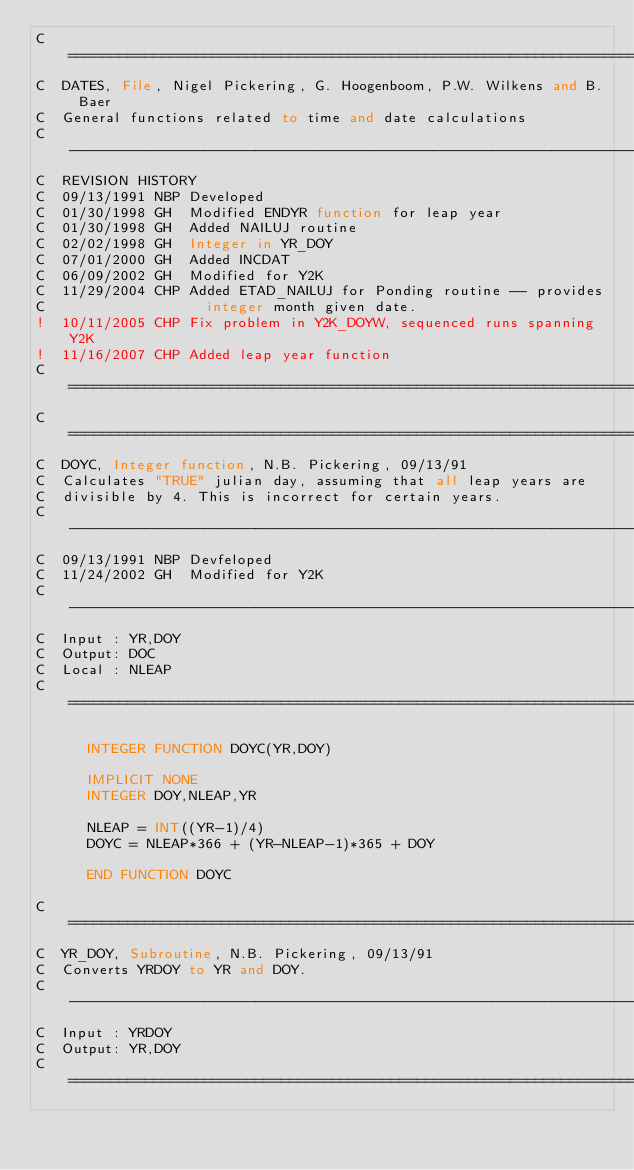Convert code to text. <code><loc_0><loc_0><loc_500><loc_500><_FORTRAN_>C=======================================================================
C  DATES, File, Nigel Pickering, G. Hoogenboom, P.W. Wilkens and B. Baer
C  General functions related to time and date calculations
C-----------------------------------------------------------------------
C  REVISION HISTORY
C  09/13/1991 NBP Developed
C  01/30/1998 GH  Modified ENDYR function for leap year
C  01/30/1998 GH  Added NAILUJ routine
C  02/02/1998 GH  Integer in YR_DOY
C  07/01/2000 GH  Added INCDAT
C  06/09/2002 GH  Modified for Y2K
C  11/29/2004 CHP Added ETAD_NAILUJ for Ponding routine -- provides 
C                   integer month given date.
!  10/11/2005 CHP Fix problem in Y2K_DOYW, sequenced runs spanning Y2K 
!  11/16/2007 CHP Added leap year function
C=======================================================================
C=======================================================================
C  DOYC, Integer function, N.B. Pickering, 09/13/91
C  Calculates "TRUE" julian day, assuming that all leap years are 
C  divisible by 4. This is incorrect for certain years.
C-----------------------------------------------------------------------
C  09/13/1991 NBP Devfeloped
C  11/24/2002 GH  Modified for Y2K
C-----------------------------------------------------------------------
C  Input : YR,DOY
C  Output: DOC
C  Local : NLEAP
C=======================================================================

      INTEGER FUNCTION DOYC(YR,DOY)

      IMPLICIT NONE
      INTEGER DOY,NLEAP,YR

      NLEAP = INT((YR-1)/4)
      DOYC = NLEAP*366 + (YR-NLEAP-1)*365 + DOY

      END FUNCTION DOYC

C=======================================================================
C  YR_DOY, Subroutine, N.B. Pickering, 09/13/91
C  Converts YRDOY to YR and DOY.
C-----------------------------------------------------------------------
C  Input : YRDOY
C  Output: YR,DOY
C=======================================================================
</code> 